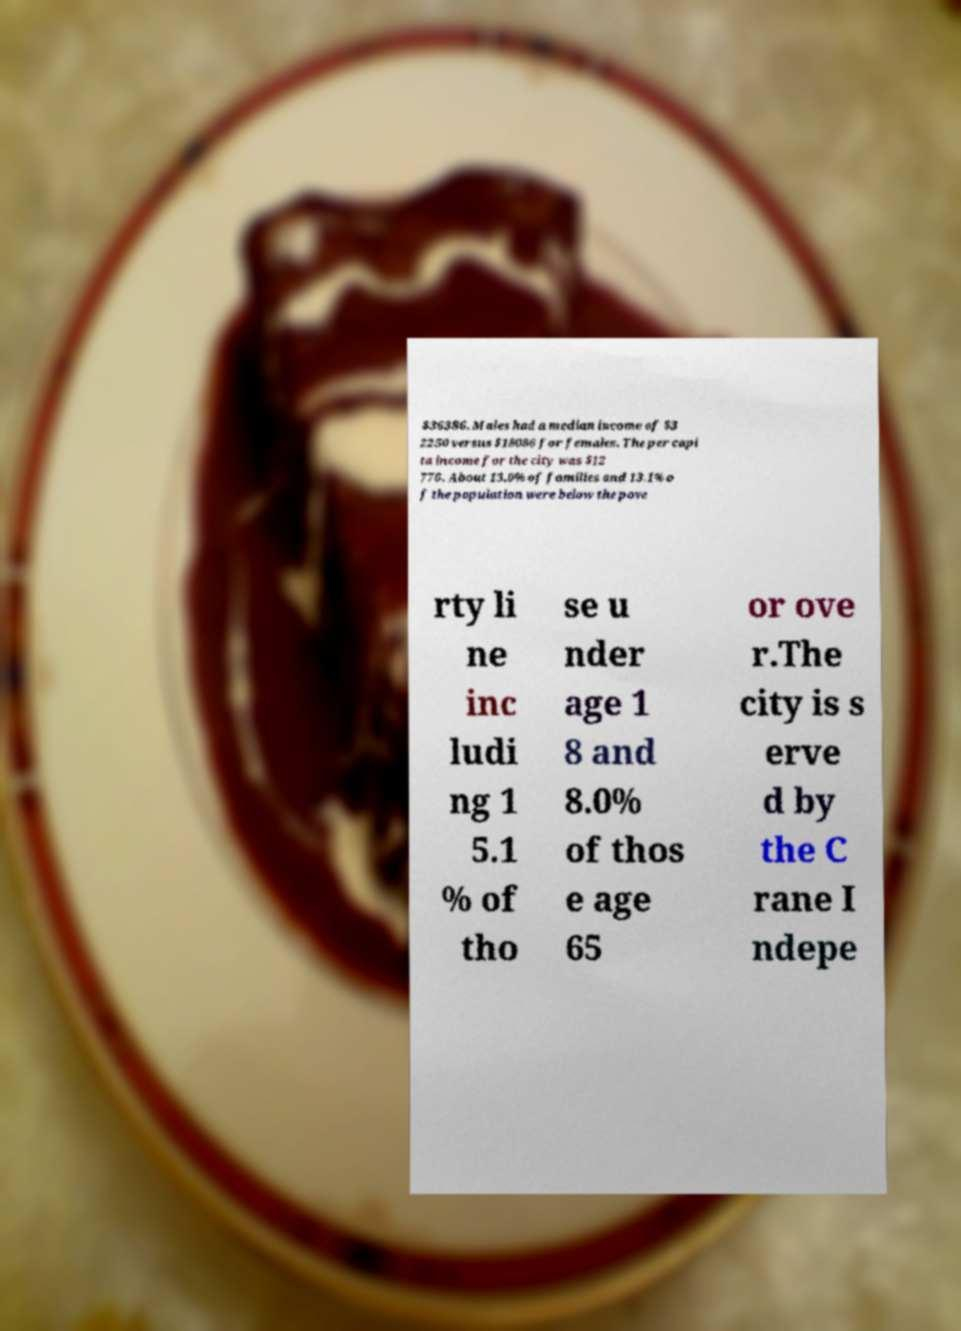Please read and relay the text visible in this image. What does it say? $36386. Males had a median income of $3 2250 versus $18086 for females. The per capi ta income for the city was $12 776. About 13.0% of families and 13.1% o f the population were below the pove rty li ne inc ludi ng 1 5.1 % of tho se u nder age 1 8 and 8.0% of thos e age 65 or ove r.The city is s erve d by the C rane I ndepe 